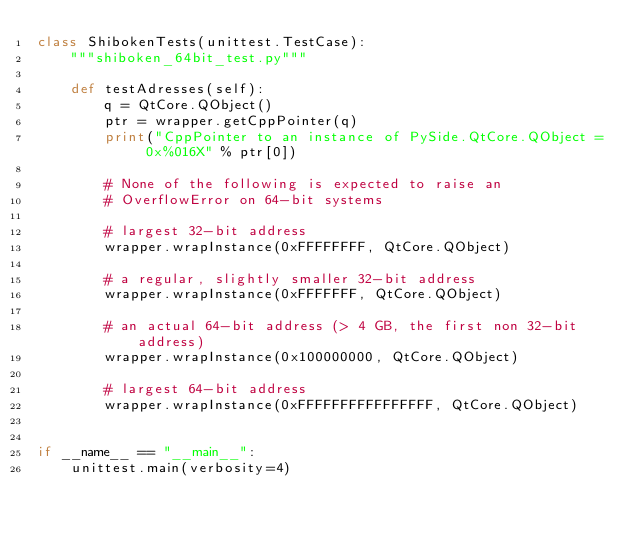<code> <loc_0><loc_0><loc_500><loc_500><_Python_>class ShibokenTests(unittest.TestCase):
    """shiboken_64bit_test.py"""

    def testAdresses(self):
        q = QtCore.QObject()
        ptr = wrapper.getCppPointer(q)
        print("CppPointer to an instance of PySide.QtCore.QObject = 0x%016X" % ptr[0])

        # None of the following is expected to raise an
        # OverflowError on 64-bit systems

        # largest 32-bit address
        wrapper.wrapInstance(0xFFFFFFFF, QtCore.QObject)

        # a regular, slightly smaller 32-bit address
        wrapper.wrapInstance(0xFFFFFFF, QtCore.QObject)

        # an actual 64-bit address (> 4 GB, the first non 32-bit address)
        wrapper.wrapInstance(0x100000000, QtCore.QObject)

        # largest 64-bit address
        wrapper.wrapInstance(0xFFFFFFFFFFFFFFFF, QtCore.QObject)


if __name__ == "__main__":
    unittest.main(verbosity=4)
</code> 